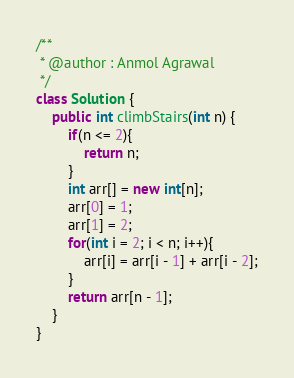Convert code to text. <code><loc_0><loc_0><loc_500><loc_500><_Java_>/**
 * @author : Anmol Agrawal
 */
class Solution {
    public int climbStairs(int n) {
        if(n <= 2){
            return n;
        }
        int arr[] = new int[n];
        arr[0] = 1;
        arr[1] = 2;
        for(int i = 2; i < n; i++){
            arr[i] = arr[i - 1] + arr[i - 2];
        }
        return arr[n - 1];
    }
}</code> 